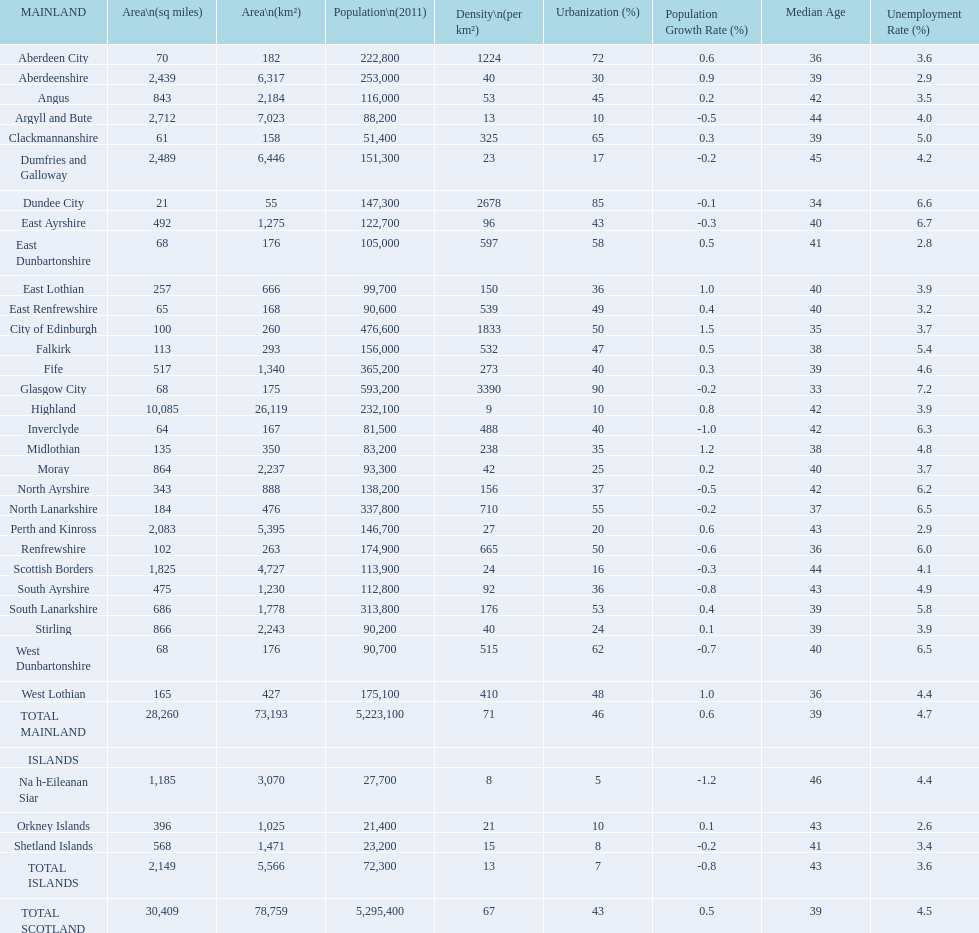If you were to arrange the locations from the smallest to largest area, which one would be first on the list? Dundee City. 